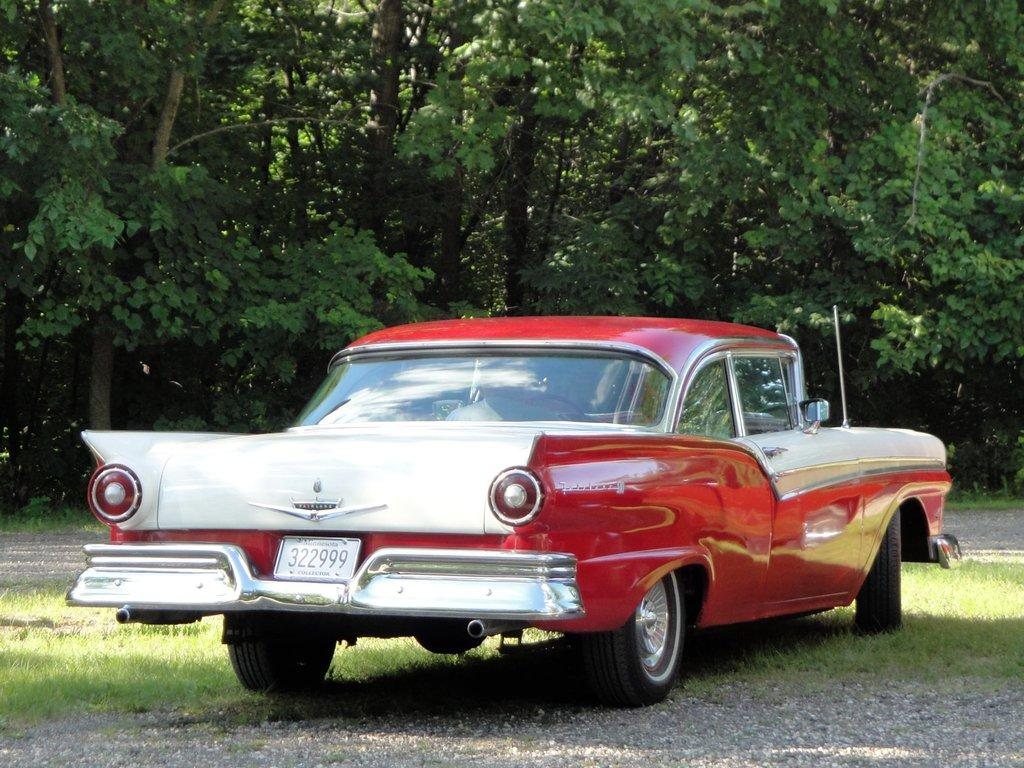What is the main subject of the image? There is a vehicle in the image. What colors can be seen on the vehicle? The vehicle has a white and red color scheme. What can be seen in the background of the image? There are trees in the background of the image. What is the color of the trees? The trees are green in color. What type of noise can be heard coming from the vehicle in the image? There is no indication of any noise in the image, as it is a still photograph. 